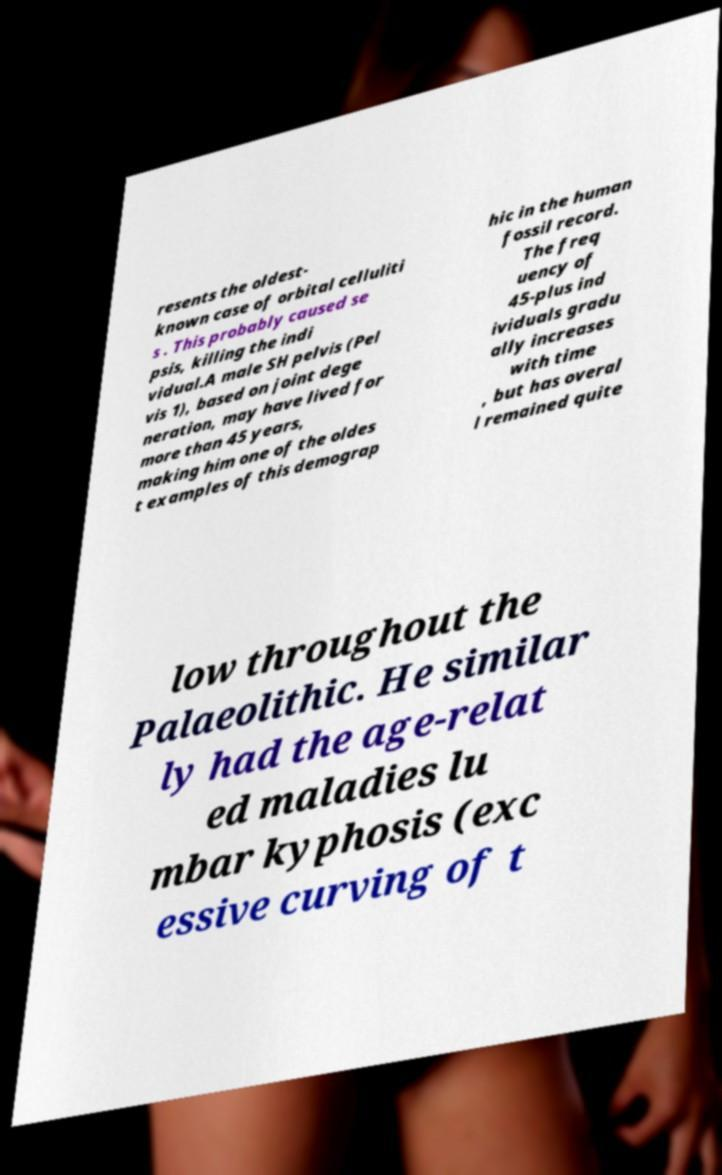Please read and relay the text visible in this image. What does it say? resents the oldest- known case of orbital celluliti s . This probably caused se psis, killing the indi vidual.A male SH pelvis (Pel vis 1), based on joint dege neration, may have lived for more than 45 years, making him one of the oldes t examples of this demograp hic in the human fossil record. The freq uency of 45-plus ind ividuals gradu ally increases with time , but has overal l remained quite low throughout the Palaeolithic. He similar ly had the age-relat ed maladies lu mbar kyphosis (exc essive curving of t 